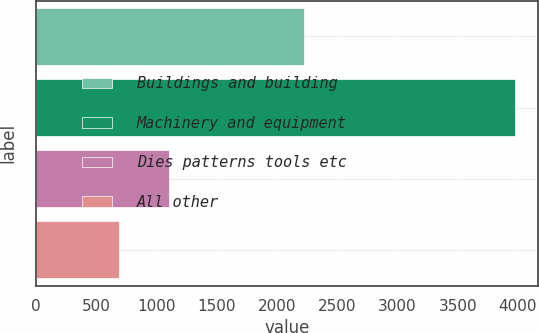Convert chart to OTSL. <chart><loc_0><loc_0><loc_500><loc_500><bar_chart><fcel>Buildings and building<fcel>Machinery and equipment<fcel>Dies patterns tools etc<fcel>All other<nl><fcel>2226<fcel>3972<fcel>1105<fcel>685<nl></chart> 